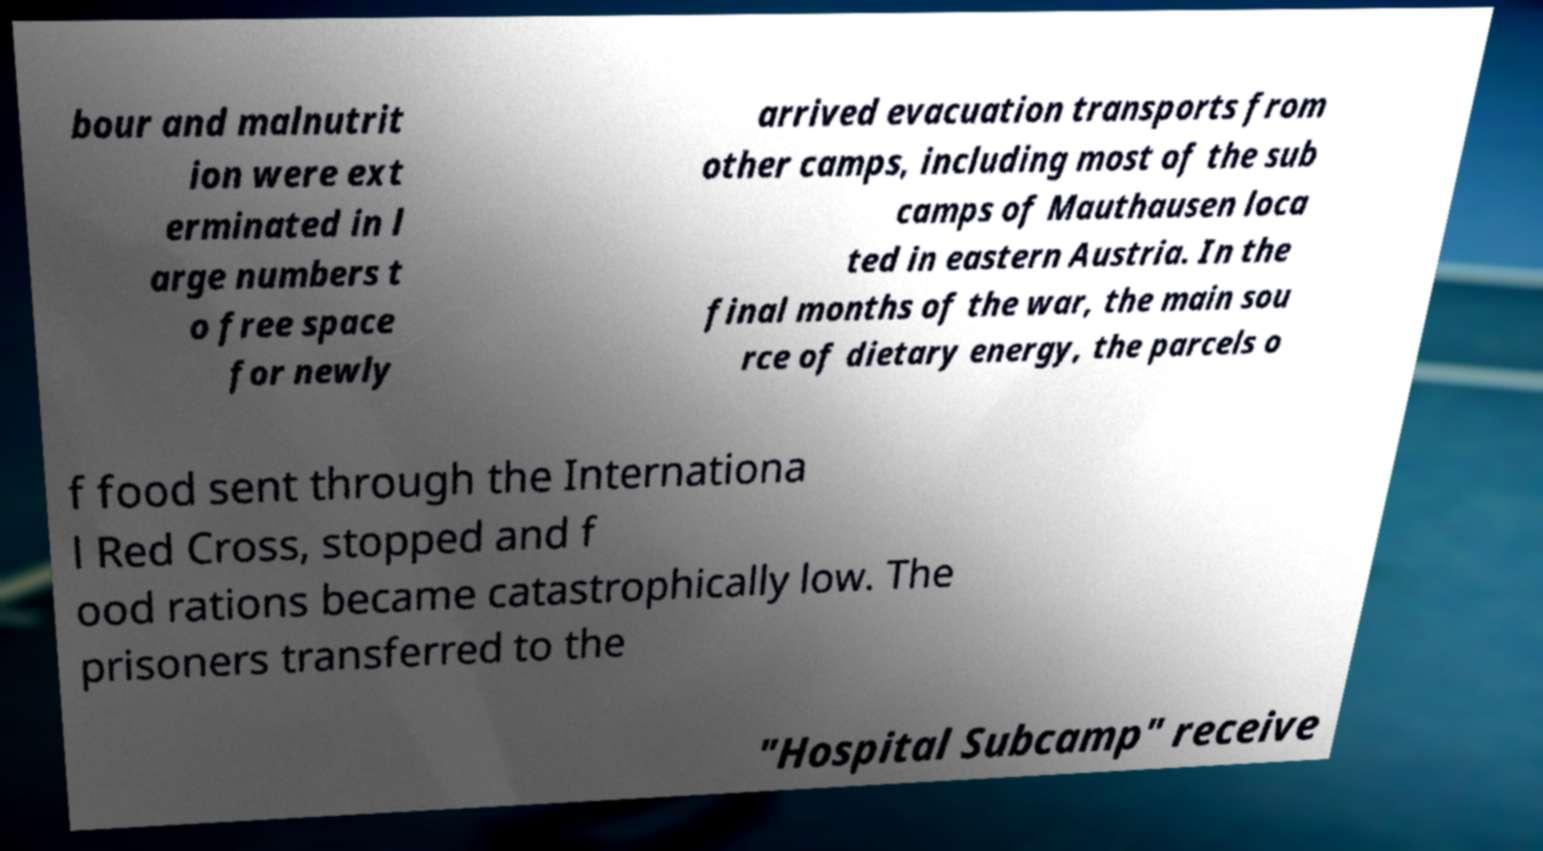Can you accurately transcribe the text from the provided image for me? bour and malnutrit ion were ext erminated in l arge numbers t o free space for newly arrived evacuation transports from other camps, including most of the sub camps of Mauthausen loca ted in eastern Austria. In the final months of the war, the main sou rce of dietary energy, the parcels o f food sent through the Internationa l Red Cross, stopped and f ood rations became catastrophically low. The prisoners transferred to the "Hospital Subcamp" receive 